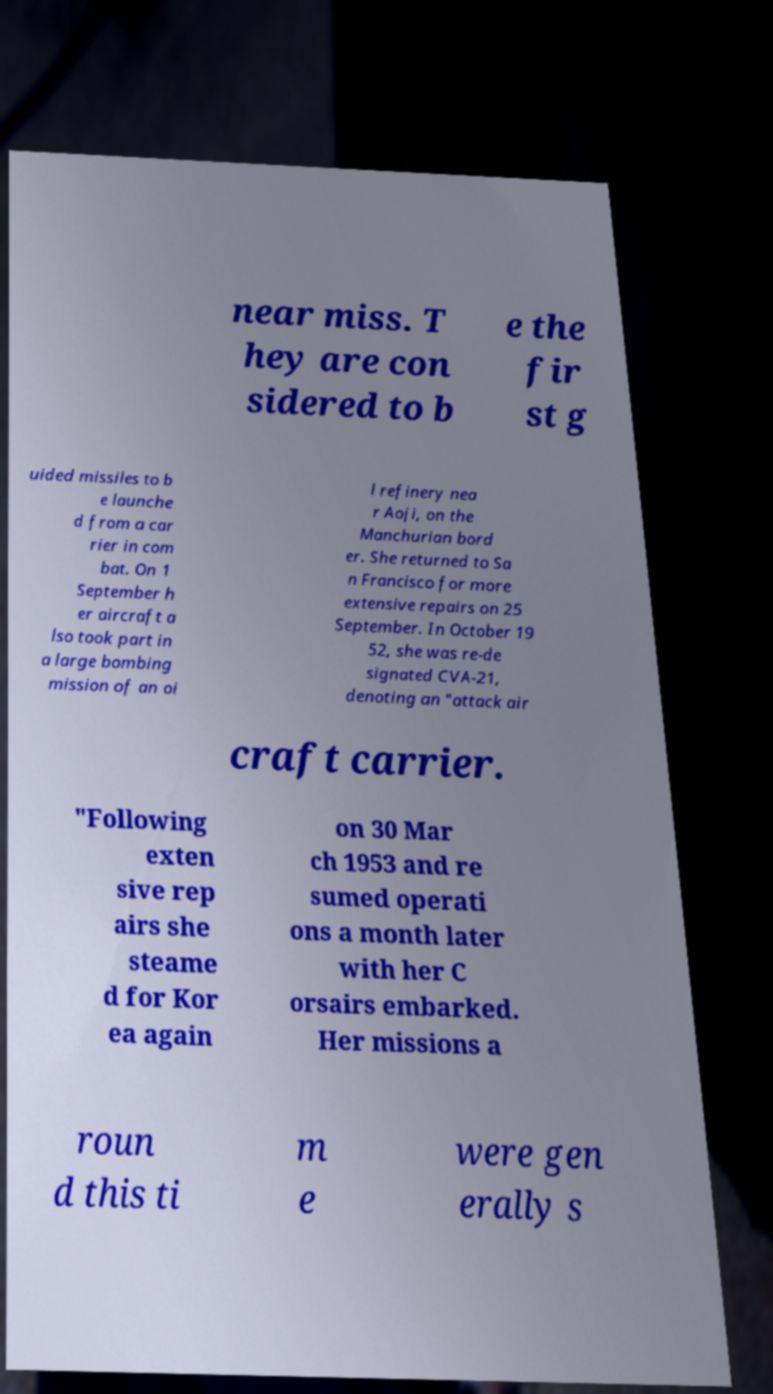Could you extract and type out the text from this image? near miss. T hey are con sidered to b e the fir st g uided missiles to b e launche d from a car rier in com bat. On 1 September h er aircraft a lso took part in a large bombing mission of an oi l refinery nea r Aoji, on the Manchurian bord er. She returned to Sa n Francisco for more extensive repairs on 25 September. In October 19 52, she was re-de signated CVA-21, denoting an "attack air craft carrier. "Following exten sive rep airs she steame d for Kor ea again on 30 Mar ch 1953 and re sumed operati ons a month later with her C orsairs embarked. Her missions a roun d this ti m e were gen erally s 